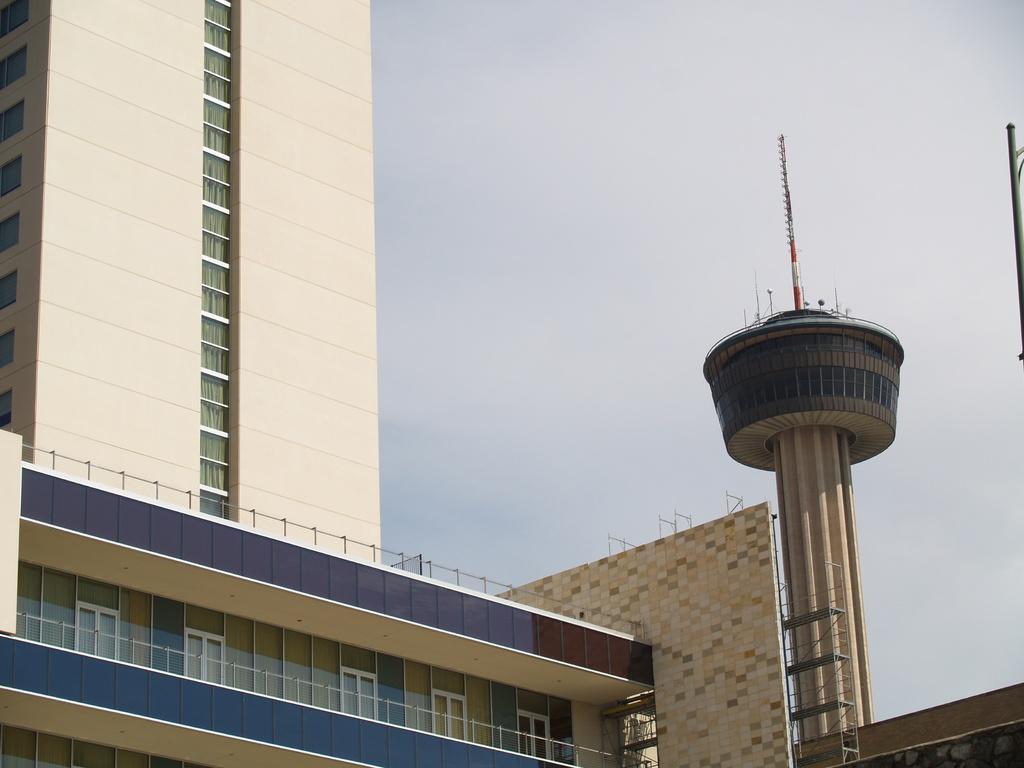Could you give a brief overview of what you see in this image? In this picture we can observe a cream and blue color building. There is a tower on the right side. In the background we can observe a sky. 